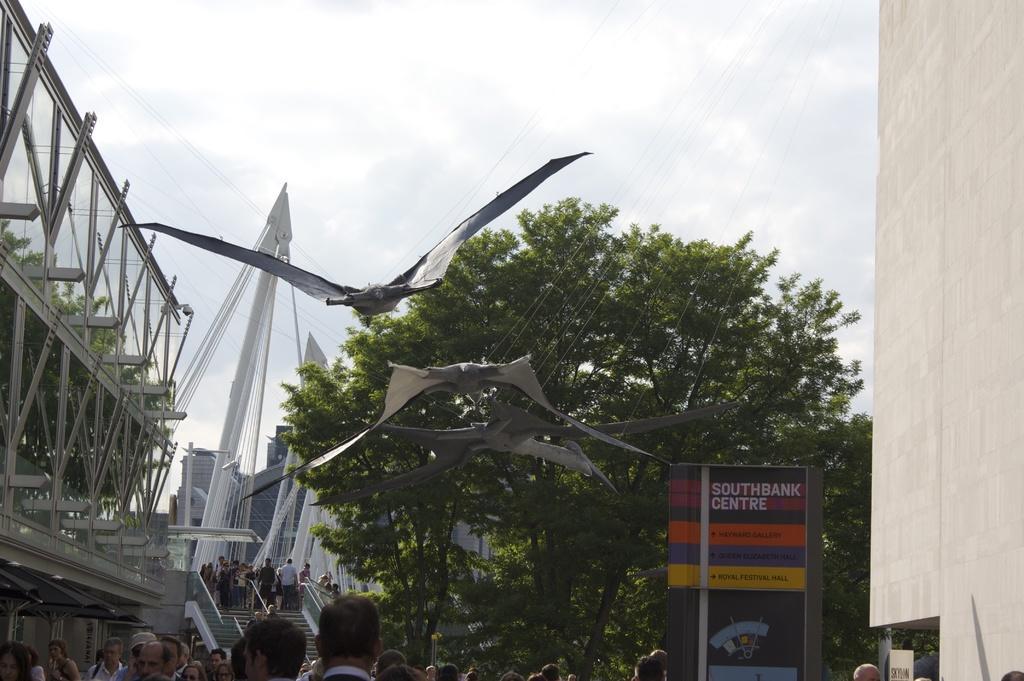Describe this image in one or two sentences. In this image at the bottom there are some people, and in the center there is a staircase and there are some persons on the staircase. And in the foreground there are some birds and some ropes, on the left side there are some towers and trees. And in the background also there are some buildings and trees, on the right side there is a wall and some board. On the board there is some text, at the top of the image there is some text. 